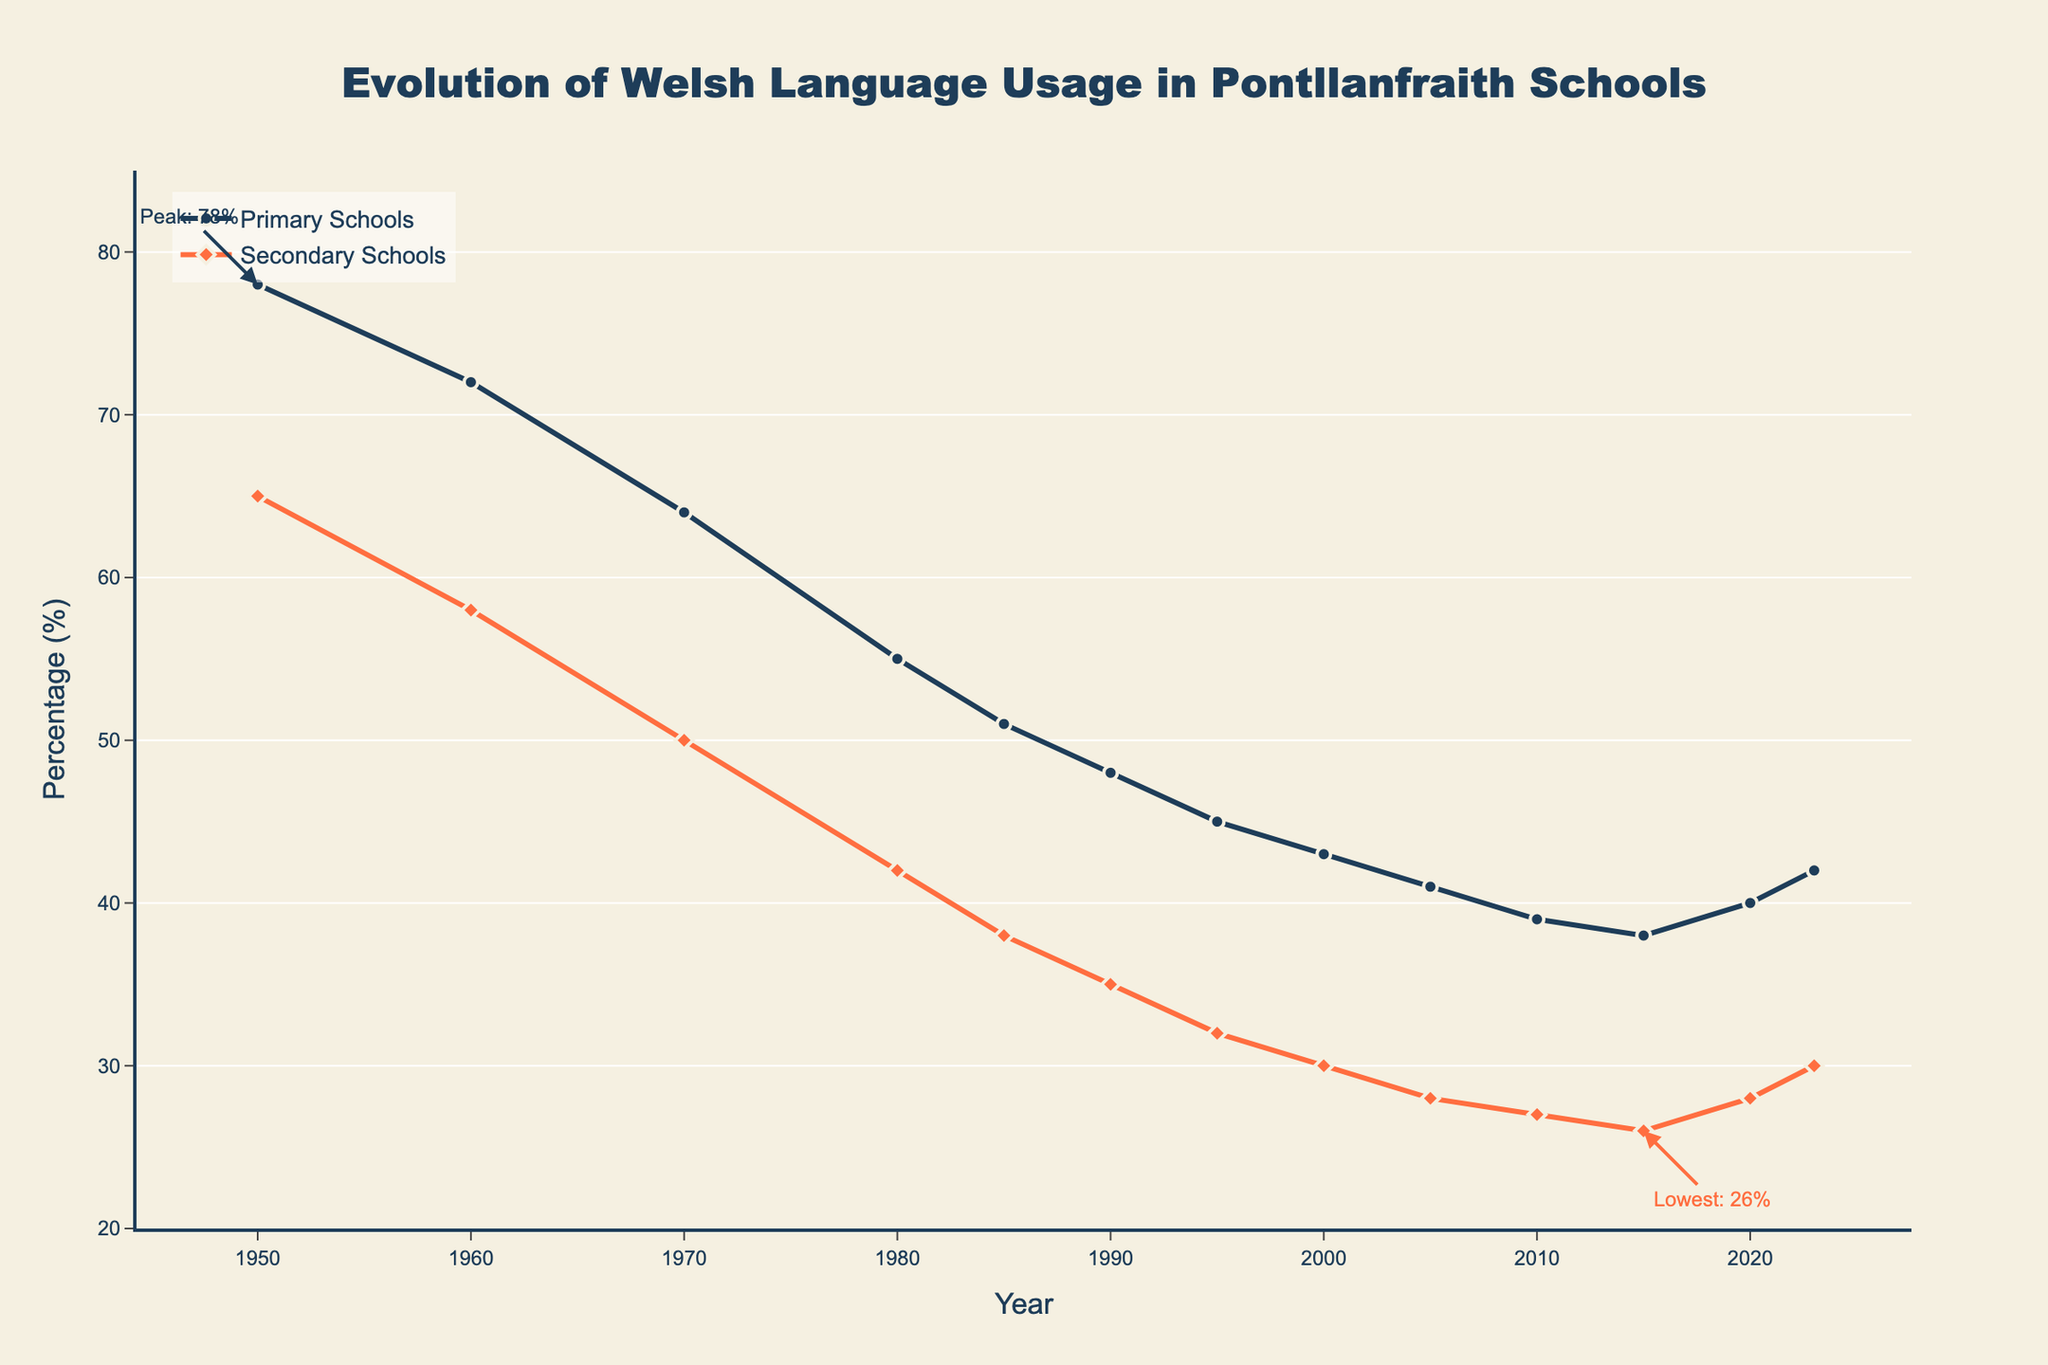What is the overall trend in Welsh language usage in primary schools from 1950 to 2023? The line chart shows a decreasing trend in Welsh language usage in primary schools from 78% in 1950 to a low of 38% in 2015, before slightly increasing to 42% in 2023. We can trace the dip and slight rise at the end by visually following the line from left to right on the chart.
Answer: Decreasing trend with slight rise at the end Which education level experienced a larger decline in Welsh language usage from 1950 to 1980? By comparing the two lines, we see that Welsh language usage in primary schools fell from 78% to 55%, a difference of 23 percentage points. In secondary schools, it fell from 65% to 42%, a difference of 23 percentage points. Therefore, both levels experienced an equal decline.
Answer: Equal decline What was the lowest recorded Welsh language usage in secondary schools, and in which year did it occur? The annotation in the chart indicates that the lowest recorded usage in secondary schools was 26% in 2015. This can be confirmed by looking at the lowest point on the orange line along the x-axis marked at 2015.
Answer: 26% in 2015 What difference in percentage points can be observed between primary and secondary schools in 2020? To find the difference, we look at 2020 on the x-axis. Welsh language usage in primary schools was 40%, and it was 28% in secondary schools. The difference is computed as 40% - 28%.
Answer: 12 percentage points Compare the Welsh language usage in primary and secondary schools in 1960. Which was higher, and by how much? In 1960, Welsh language usage in primary schools was 72%, and in secondary schools, it was 58%. The difference is 72% - 58%.
Answer: Primary by 14 percentage points During which decade did Welsh language usage decrease the most in primary schools? By examining the steepness of the line segments between decades, the largest decrease is observed between 1970 (64%) and 1980 (55%), a difference of 9 percentage points.
Answer: 1970-1980 What was the combined Welsh language usage percentage for primary and secondary schools in 2000? For 2000, add the primary and secondary percentages: 43% (primary) + 30% (secondary) = 73%.
Answer: 73% How did Welsh language usage in primary schools change between 2000 and 2023? From 2000 to 2023, Welsh language usage increased from 43% to 42%, showing a minor decline overall. The initial drop to 38% in 2015 is also noted. We compare these values directly from the chart.
Answer: Decreased slightly Which year marked a slight recovery in Welsh language usage in primary schools after a consistent decline, and what was the percentage? The primary schools' line shows a slight increase begins between 2015 and 2020. In 2020, it recovered to 40% from the low of 38% in 2015.
Answer: 2015, 40% 